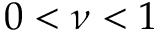<formula> <loc_0><loc_0><loc_500><loc_500>0 < \nu < 1</formula> 